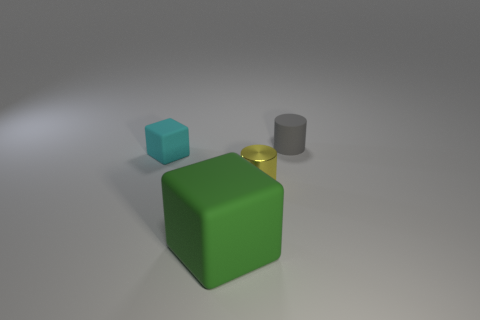Add 1 gray rubber cylinders. How many objects exist? 5 Add 4 gray matte objects. How many gray matte objects are left? 5 Add 3 cyan rubber objects. How many cyan rubber objects exist? 4 Subtract 0 red balls. How many objects are left? 4 Subtract all cyan cubes. Subtract all green cylinders. How many cubes are left? 1 Subtract all gray blocks. How many yellow cylinders are left? 1 Subtract all large gray spheres. Subtract all rubber cubes. How many objects are left? 2 